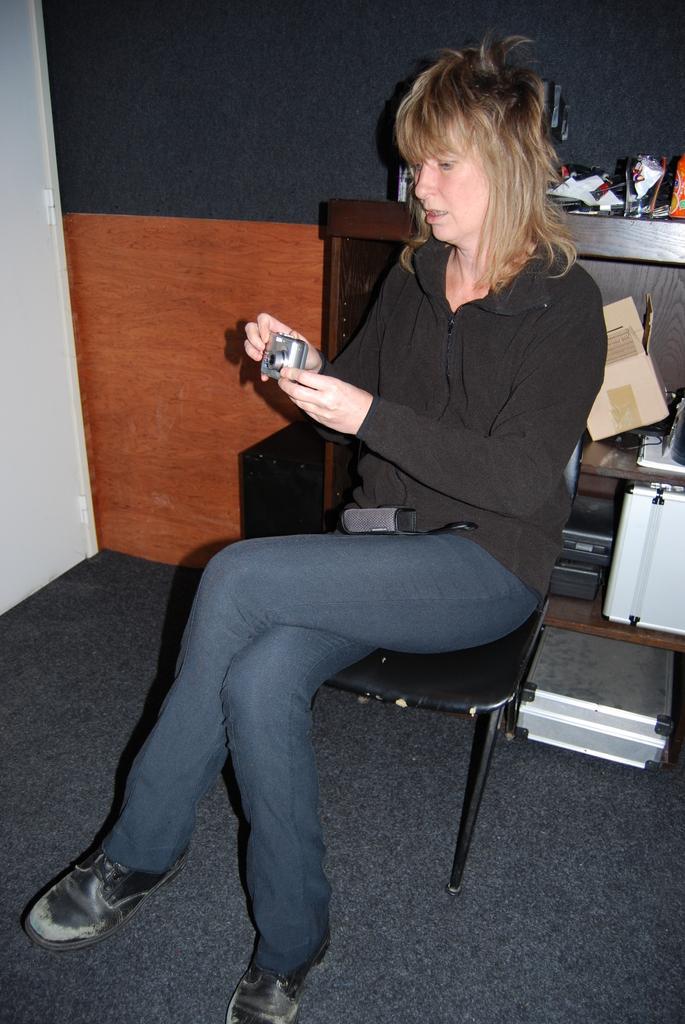How would you summarize this image in a sentence or two? There is a woman sitting on the chair and she is holding a camera with her hands. This is floor. In the background we can see a cardboard, box, and devices. This is wall. 